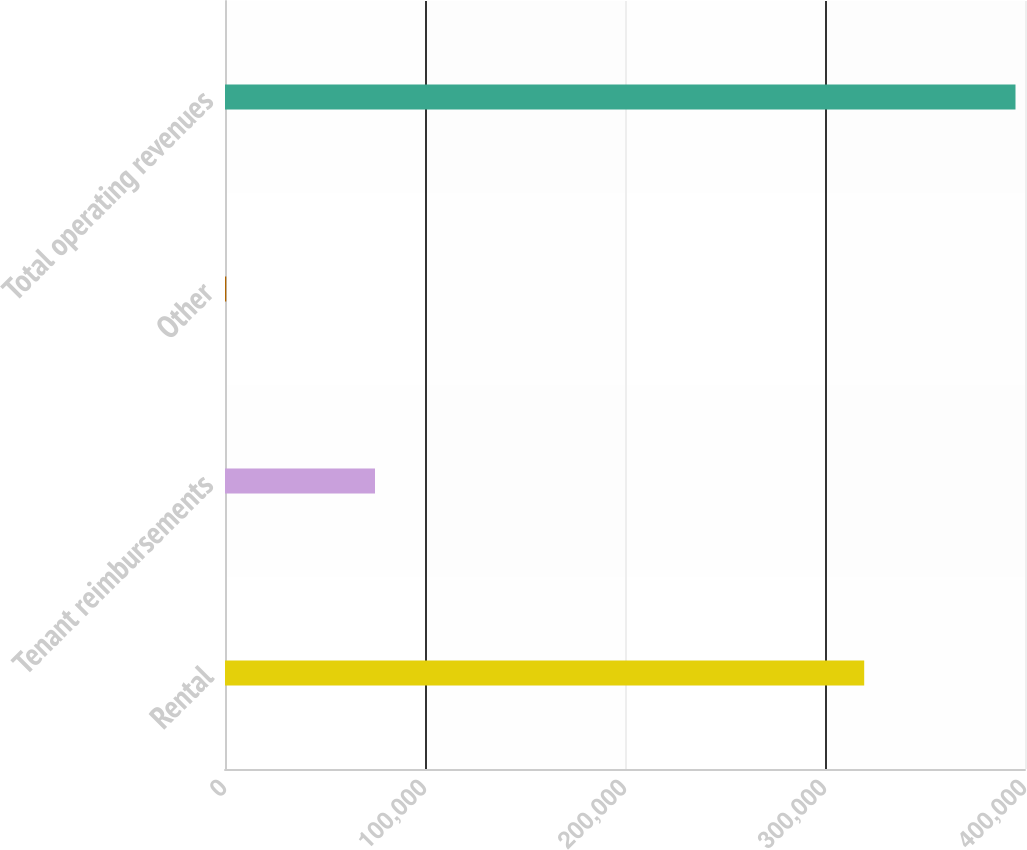Convert chart to OTSL. <chart><loc_0><loc_0><loc_500><loc_500><bar_chart><fcel>Rental<fcel>Tenant reimbursements<fcel>Other<fcel>Total operating revenues<nl><fcel>319603<fcel>75003<fcel>641<fcel>395247<nl></chart> 